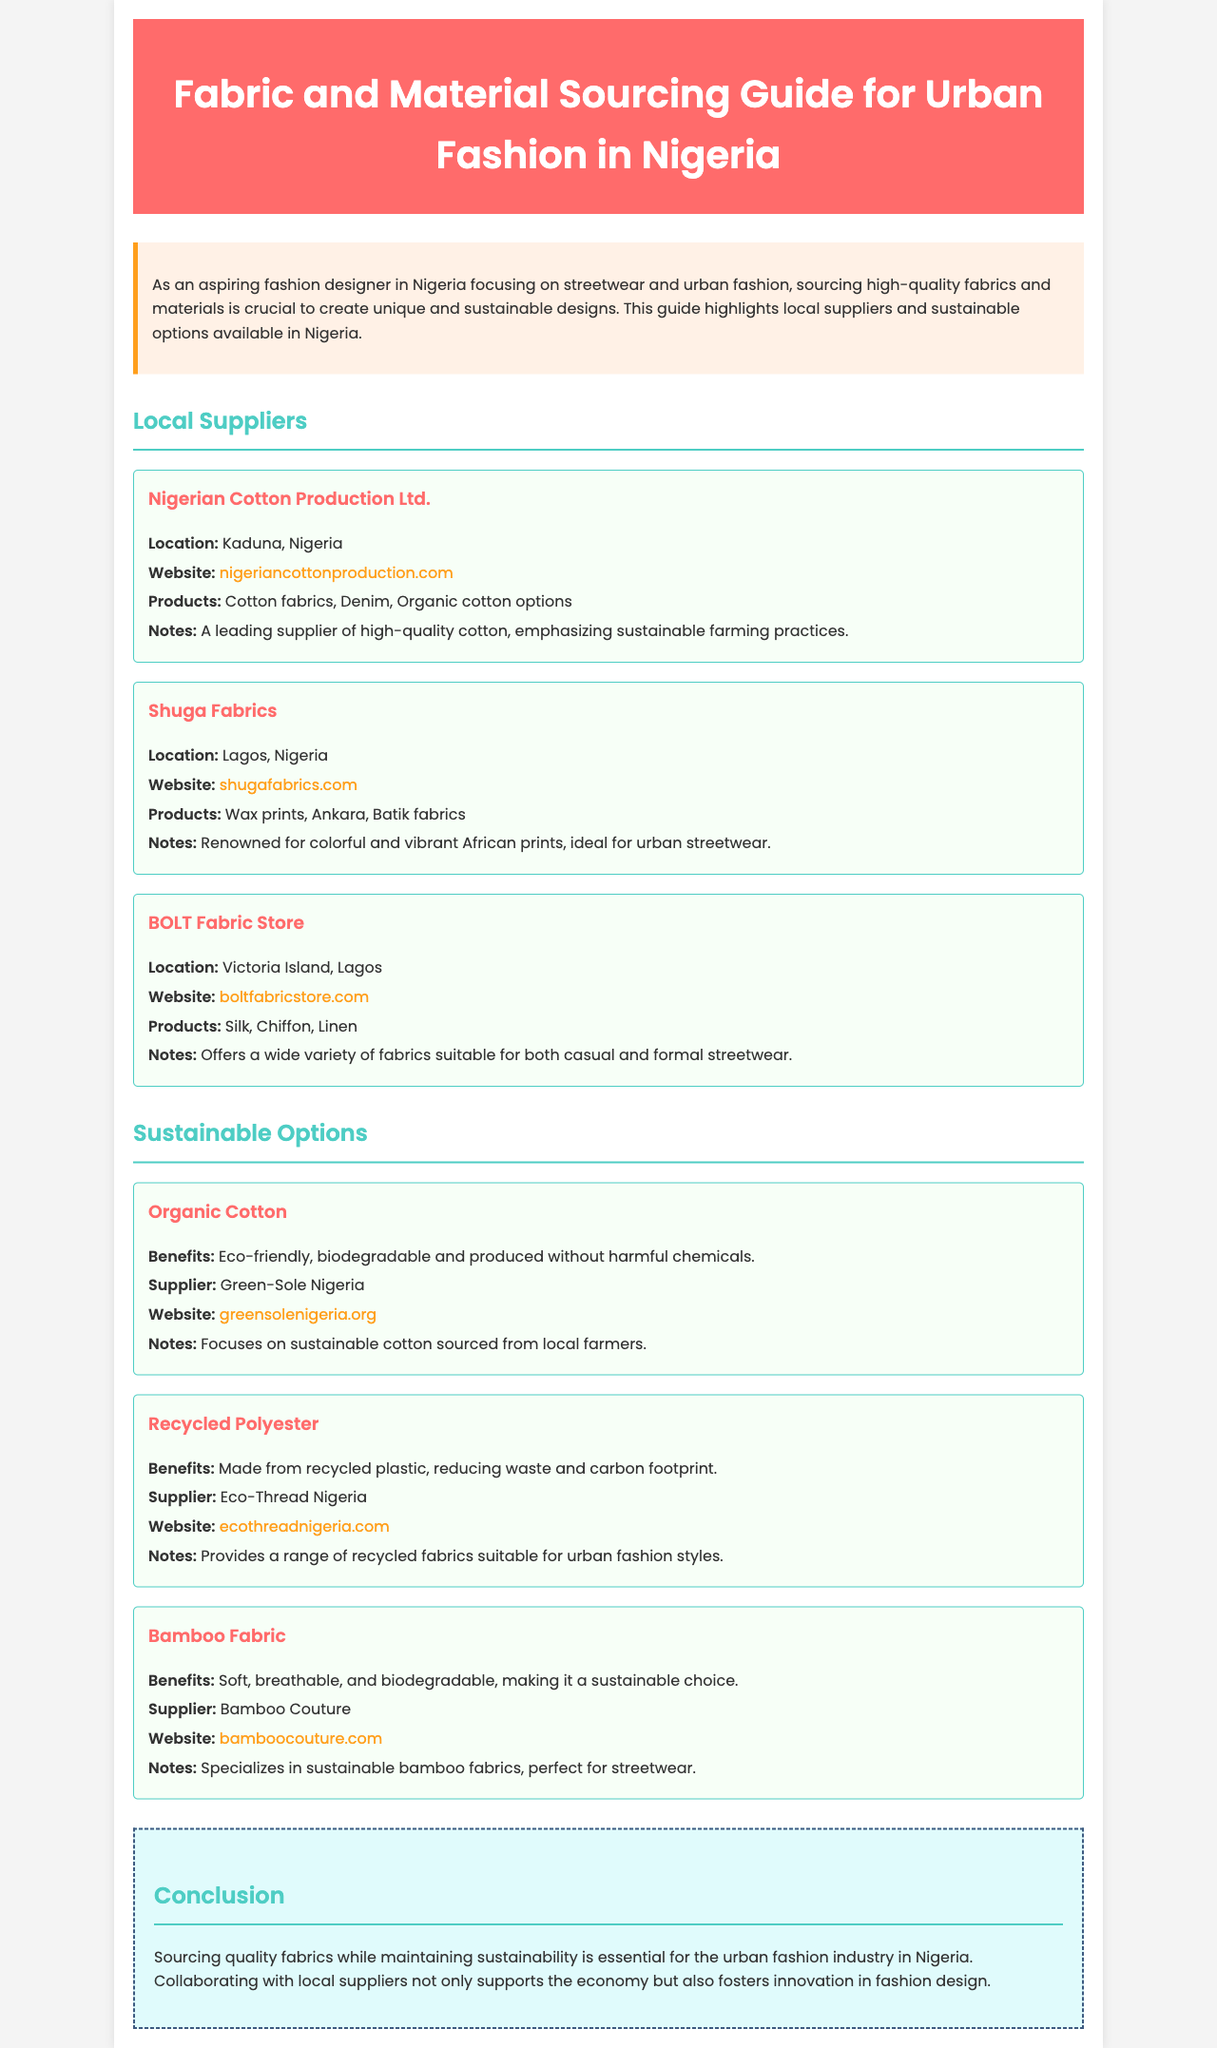What is the primary focus of the guide? The guide focuses on sourcing high-quality fabrics and materials for unique and sustainable designs in urban fashion.
Answer: Urban fashion Where is Nigerian Cotton Production Ltd. located? The location of Nigerian Cotton Production Ltd. is specified in the document.
Answer: Kaduna, Nigeria Which supplier is known for colorful African prints? The document highlights suppliers and their specialties, with specific mention of one supplier known for vibrant prints.
Answer: Shuga Fabrics What type of fabric does Eco-Thread Nigeria provide? The document outlines sustainable options and mentions a supplier that provides a specific type of recycled fabric.
Answer: Recycled Polyester What is one benefit of Bamboo Fabric? The document lists the benefits of various sustainable materials, including one for Bamboo Fabric.
Answer: Soft, breathable, and biodegradable Which supplier focuses on sustainable cotton sourced from local farmers? The document identifies a supplier that emphasizes sustainability in its cotton sourcing.
Answer: Green-Sole Nigeria What is emphasized in the conclusion of the guide? The conclusion summarizes key points regarding the importance of sourcing fabrics sustainably within a specific industry.
Answer: Supporting local suppliers How many local suppliers are listed in the guide? The document specifies the number of suppliers provided in the local suppliers section.
Answer: Three 